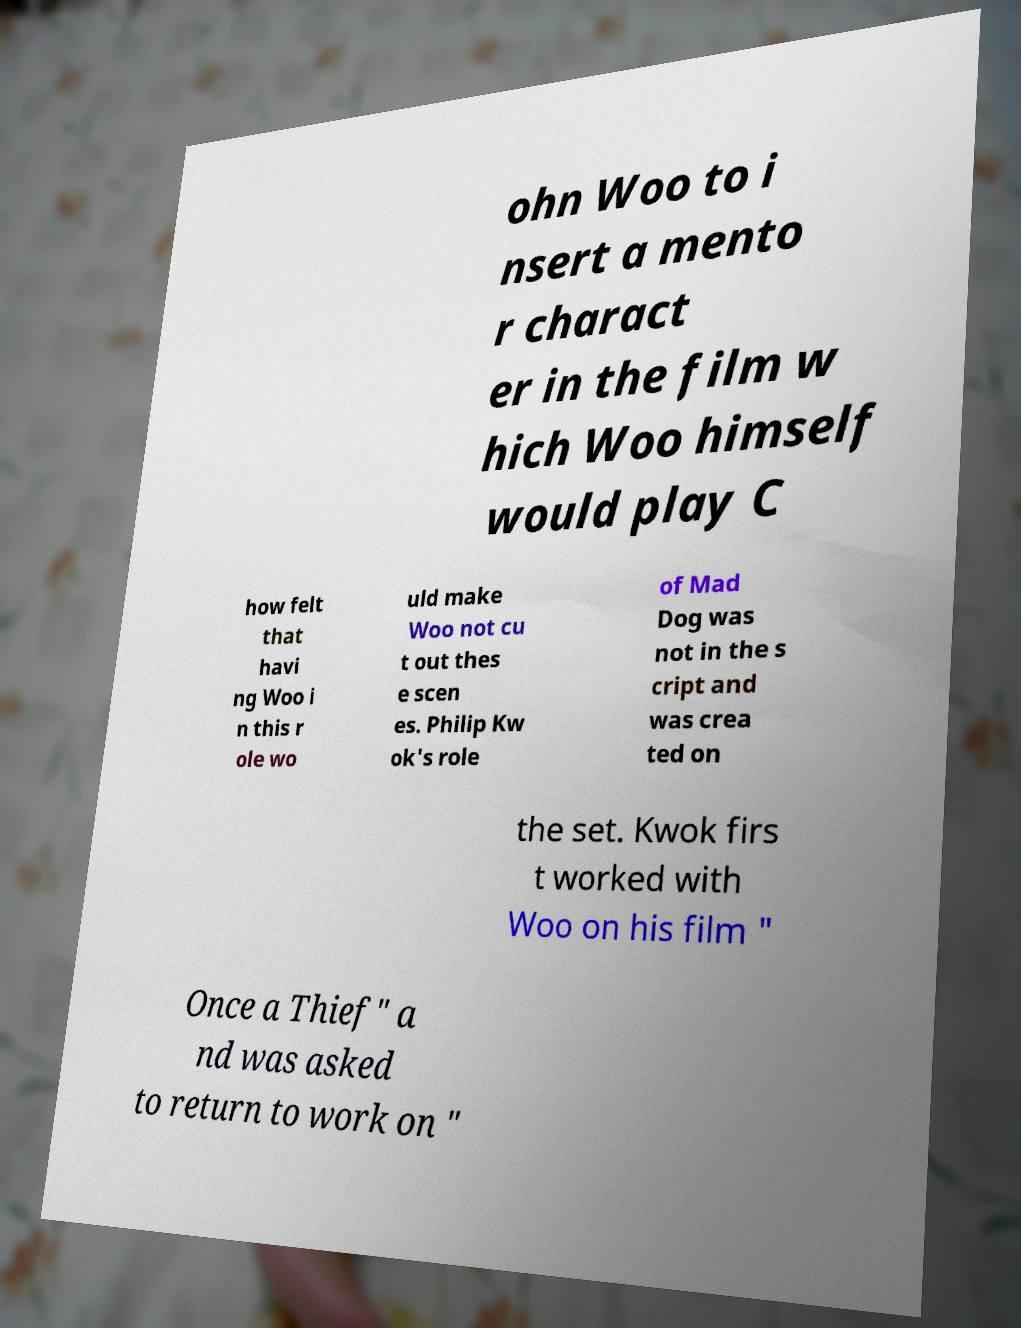Please identify and transcribe the text found in this image. ohn Woo to i nsert a mento r charact er in the film w hich Woo himself would play C how felt that havi ng Woo i n this r ole wo uld make Woo not cu t out thes e scen es. Philip Kw ok's role of Mad Dog was not in the s cript and was crea ted on the set. Kwok firs t worked with Woo on his film " Once a Thief" a nd was asked to return to work on " 